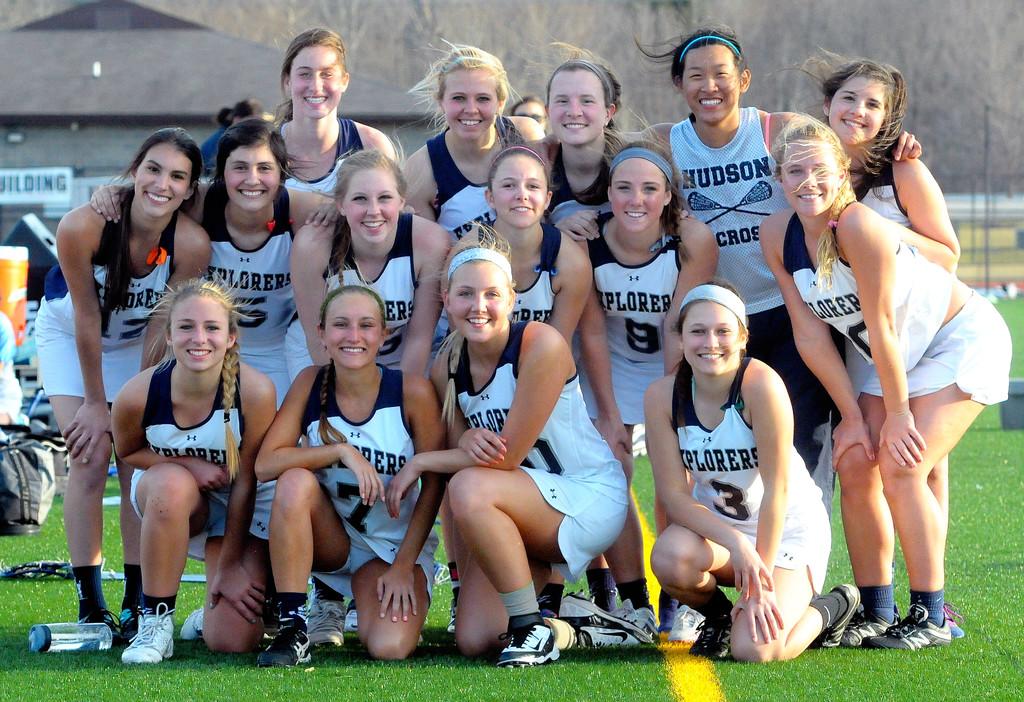What team do they play on?
Offer a terse response. Hudson. What number is the girl kneeling on the right?
Ensure brevity in your answer.  3. 